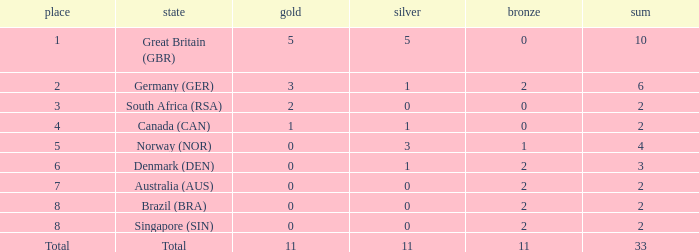Could you parse the entire table as a dict? {'header': ['place', 'state', 'gold', 'silver', 'bronze', 'sum'], 'rows': [['1', 'Great Britain (GBR)', '5', '5', '0', '10'], ['2', 'Germany (GER)', '3', '1', '2', '6'], ['3', 'South Africa (RSA)', '2', '0', '0', '2'], ['4', 'Canada (CAN)', '1', '1', '0', '2'], ['5', 'Norway (NOR)', '0', '3', '1', '4'], ['6', 'Denmark (DEN)', '0', '1', '2', '3'], ['7', 'Australia (AUS)', '0', '0', '2', '2'], ['8', 'Brazil (BRA)', '0', '0', '2', '2'], ['8', 'Singapore (SIN)', '0', '0', '2', '2'], ['Total', 'Total', '11', '11', '11', '33']]} What is the total when the nation is brazil (bra) and bronze is more than 2? None. 